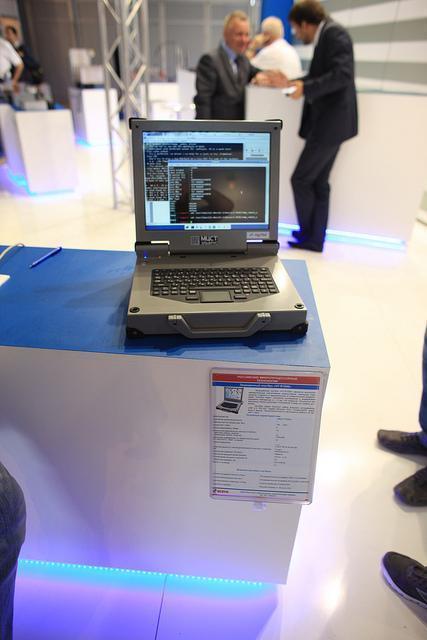How many people can you see?
Give a very brief answer. 3. 